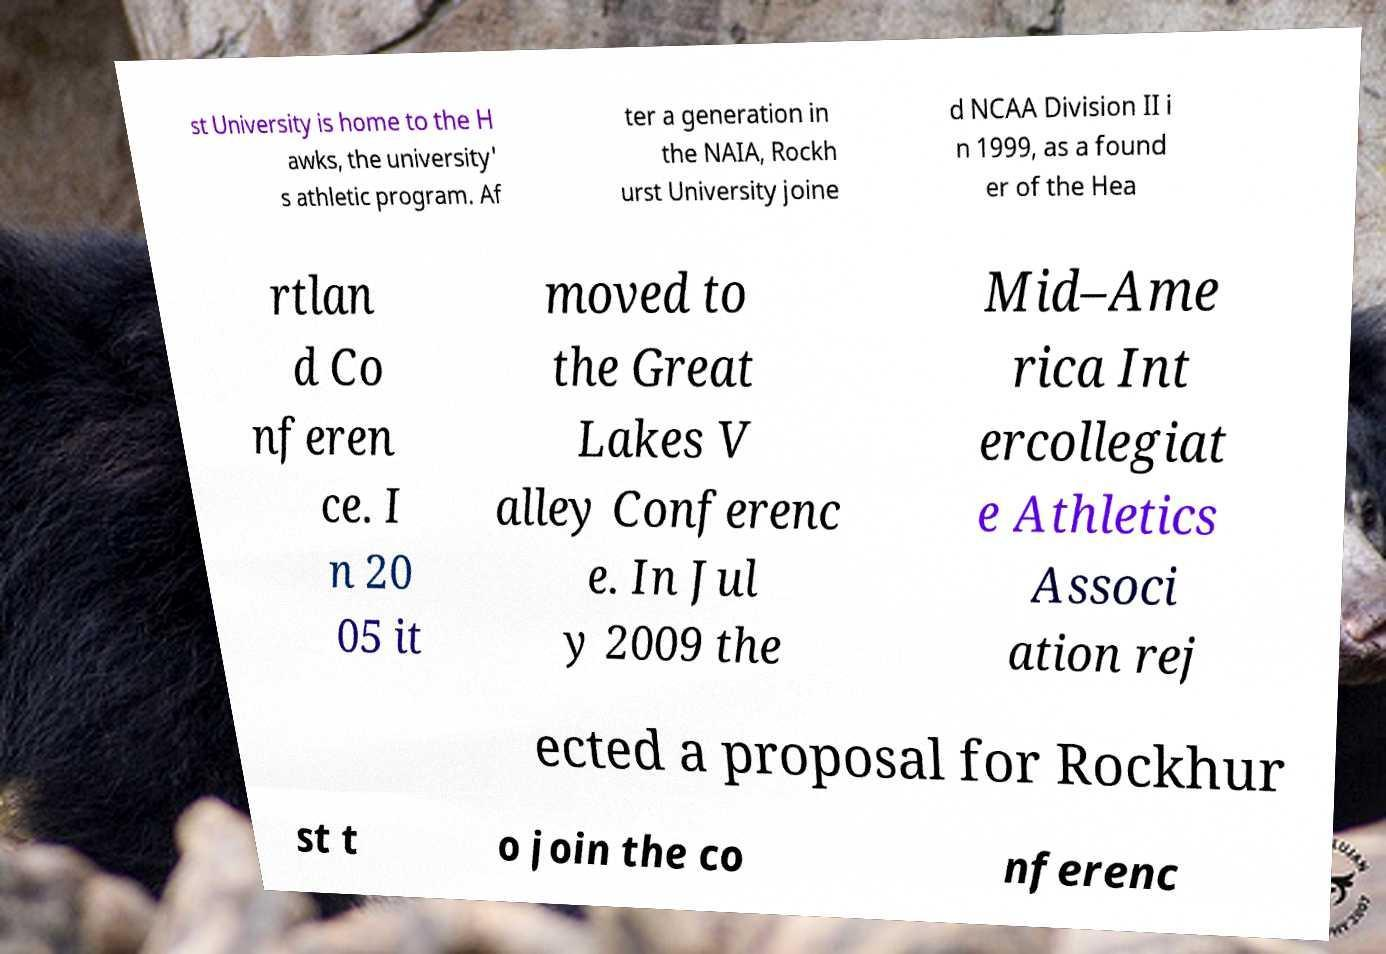What messages or text are displayed in this image? I need them in a readable, typed format. st University is home to the H awks, the university' s athletic program. Af ter a generation in the NAIA, Rockh urst University joine d NCAA Division II i n 1999, as a found er of the Hea rtlan d Co nferen ce. I n 20 05 it moved to the Great Lakes V alley Conferenc e. In Jul y 2009 the Mid–Ame rica Int ercollegiat e Athletics Associ ation rej ected a proposal for Rockhur st t o join the co nferenc 